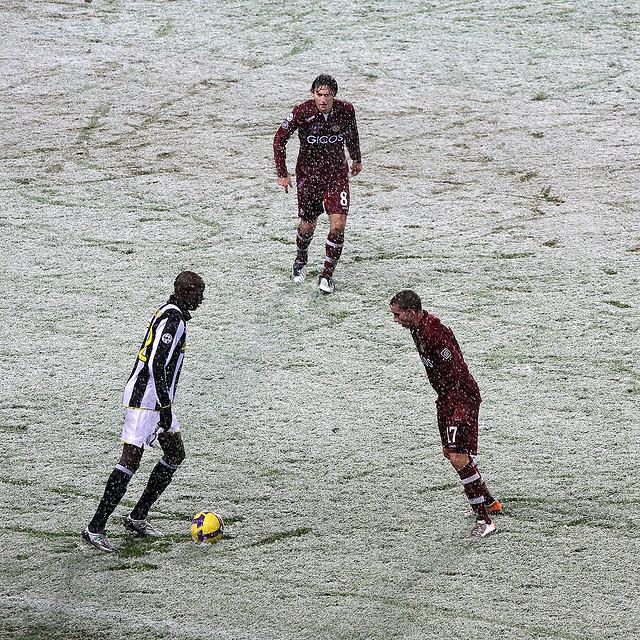What substance is covering the turf?

Choices:
A) salt
B) sand
C) ash
D) snow snow 